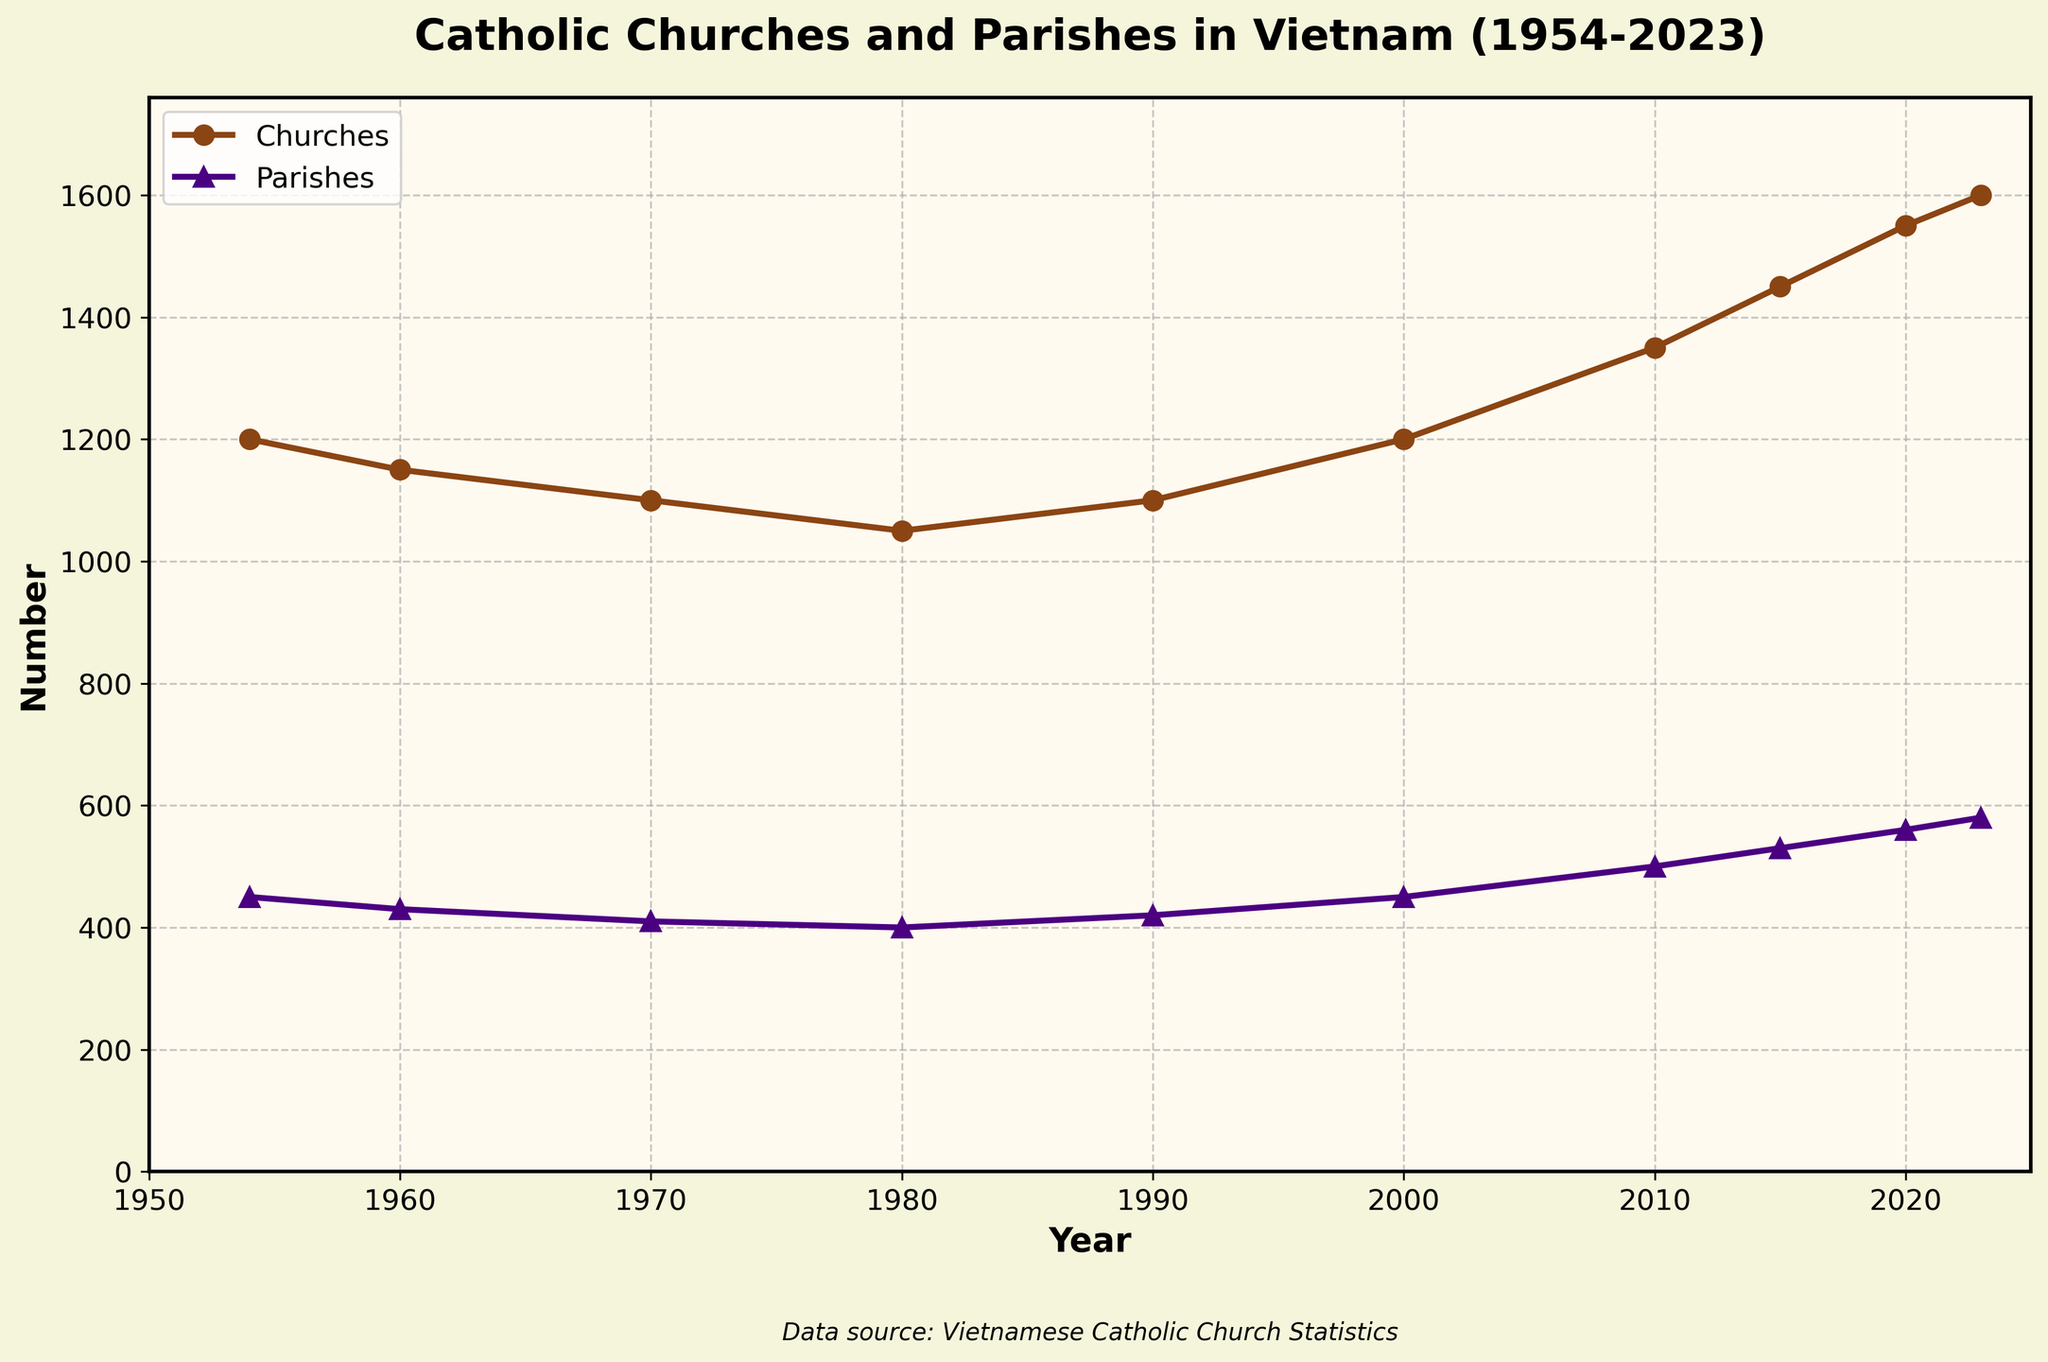How many Catholic churches were there in Vietnam in 1954 and 2023, and what is the difference between these two values? In 1954, there were 1200 Catholic churches. In 2023, there were 1600 Catholic churches. The difference is calculated as 1600 - 1200 = 400.
Answer: 400 What was the general trend in the number of Catholic parishes in Vietnam between 1954 and 2023? The general trend of Catholic parishes shows a pattern of decline until 1980, then followed by slow growth, particularly picking up between 2000 and 2023. This can be observed by tracing the line for parishes in the graph.
Answer: Increasing trend after initial decline In which decade did the number of Catholic churches in Vietnam increase the most? By comparing the increments each decade: between 1980 and 1990 (1050 to 1100), 1990 and 2000 (1100 to 1200), 2000 and 2010 (1200 to 1350), 2010 and 2020 (1350 to 1550), and 2020 and 2023 (1550 to 1600), the largest increase is observed between 2010 and 2020.
Answer: 2010-2020 How many more Catholic churches were there compared to Catholic parishes in the year 2015? In 2015, there were 1450 Catholic churches and 530 Catholic parishes. The difference is 1450 - 530 = 920.
Answer: 920 Which year between 1980 and 2000 saw the same number of Catholic churches as in 1954? In 1954, there were 1200 Catholic churches. Observing the graph, the number of churches returned to 1200 in the year 2000.
Answer: 2000 What is the average number of Catholic parishes from 1954 to 1980? The average number of Catholic parishes from 1954 (450), 1960 (430), 1970 (410), to 1980 (400) is calculated by (450 + 430 + 410 + 400) / 4 = 422.5.
Answer: 422.5 Between which years did the number of Catholic churches remain constant? From the visual observation of the line for churches, it remained constant from 1980 (1050) to 1990 (1100), but there is no exact same number for both years. Instead, a small decline.
Answer: None remained constant When did the number of Catholic parishes surpass the 500 mark? From the figure, tracing the parishes line, the number surpassed the 500 mark in 2010.
Answer: 2010 What is the percentage increase in the number of Catholic parishes from 1954 to 2023? The number of Catholic parishes increased from 450 in 1954 to 580 in 2023. The percentage increase is ((580 - 450) / 450) * 100 = 28.89%.
Answer: 28.89% 